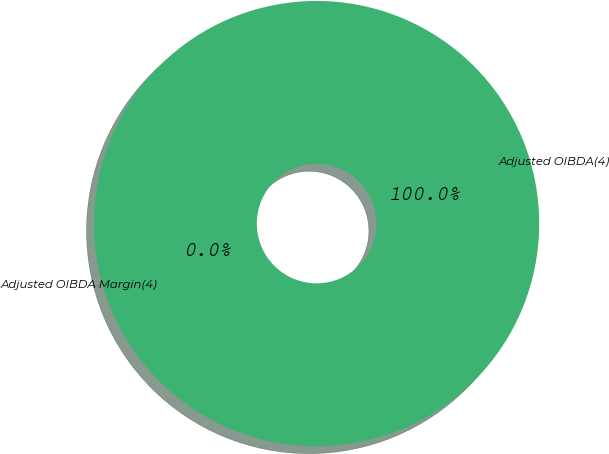Convert chart to OTSL. <chart><loc_0><loc_0><loc_500><loc_500><pie_chart><fcel>Adjusted OIBDA(4)<fcel>Adjusted OIBDA Margin(4)<nl><fcel>100.0%<fcel>0.0%<nl></chart> 